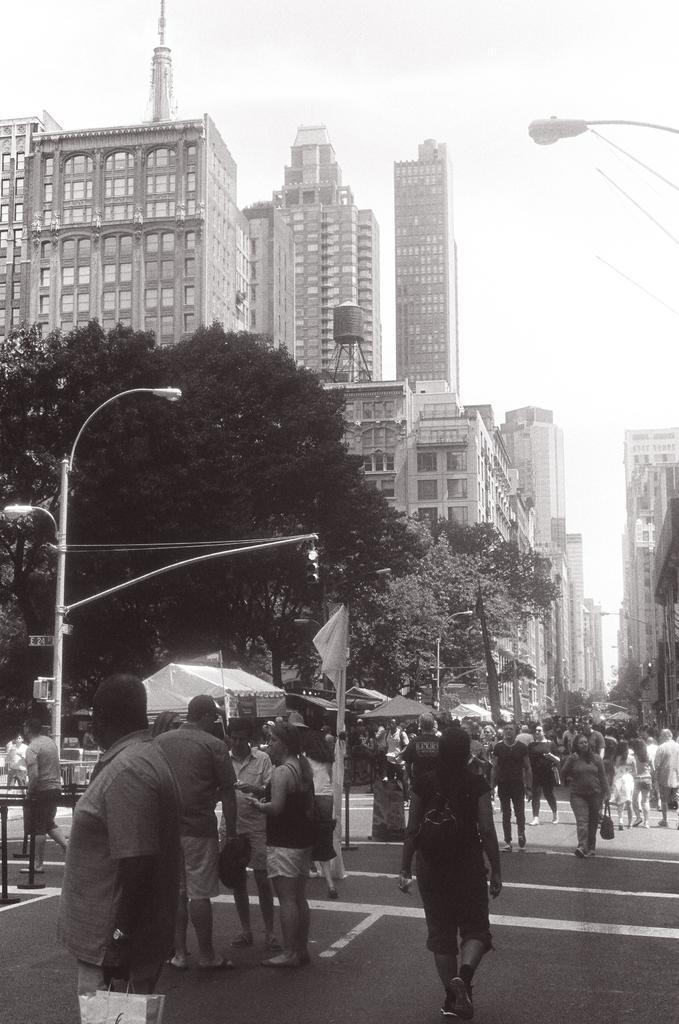Could you give a brief overview of what you see in this image? Here in this picture we can see number of people standing and walking on the road over there and we can see light posts present all over there and we can also see trees present over there and we can see buildings present on either side of the road and we can also see clouds in the sky and on the ground o the left side we can see a tent present on the road over there. 